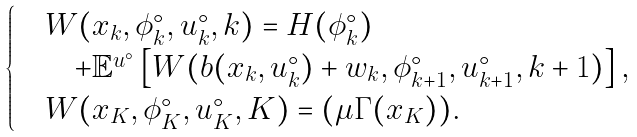Convert formula to latex. <formula><loc_0><loc_0><loc_500><loc_500>\begin{cases} & W ( x _ { k } , \phi ^ { \circ } _ { k } , u ^ { \circ } _ { k } , k ) = H ( \phi ^ { \circ } _ { k } ) \\ & \quad + \mathbb { E } ^ { u ^ { \circ } } \left [ W ( b ( x _ { k } , u ^ { \circ } _ { k } ) + w _ { k } , \phi ^ { \circ } _ { k + 1 } , u ^ { \circ } _ { k + 1 } , k + 1 ) \right ] , \\ & W ( x _ { K } , \phi ^ { \circ } _ { K } , u ^ { \circ } _ { K } , K ) = ( \mu \Gamma ( x _ { K } ) ) . \end{cases}</formula> 